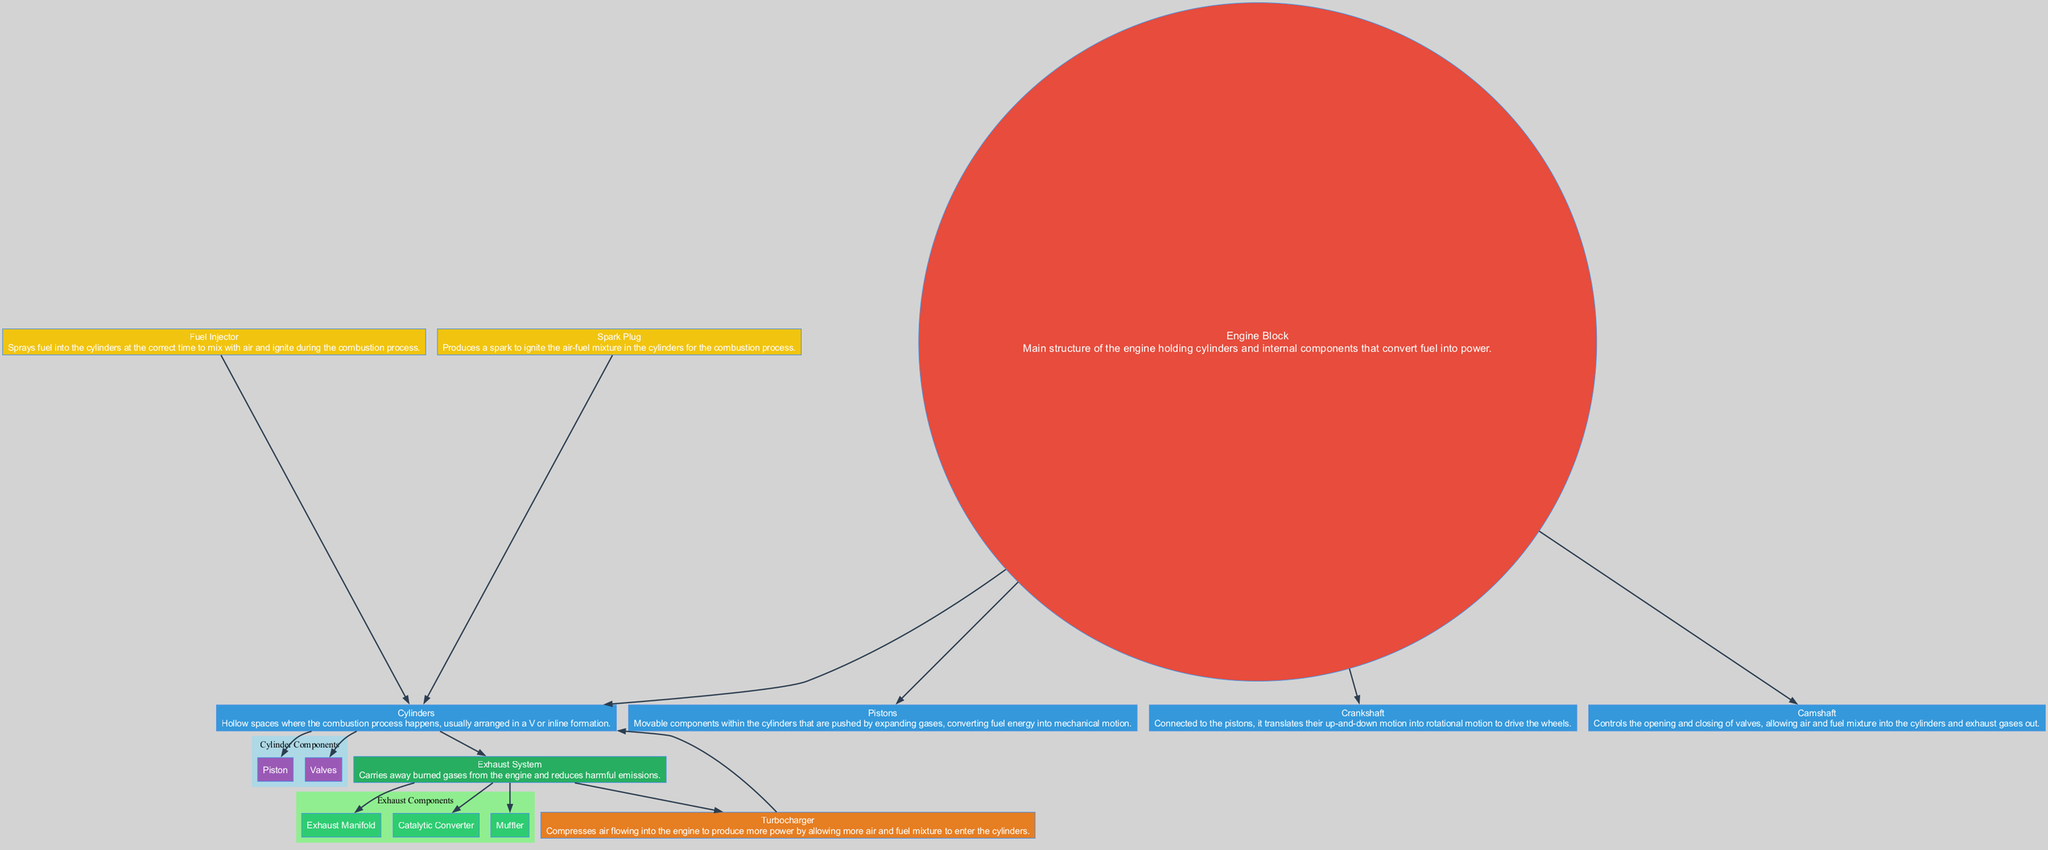What is the main structure of the engine called? The main structure, which holds the cylinders and internal components, is specifically referred to as the Engine Block.
Answer: Engine Block How many cylinders are typically present in a racing car engine? The diagram suggests that cylinders form the main component involved in combustion processes but does not specify a number. Racing car engines usually have many cylinders, often 4, 6, or 8; however, this cannot be directly determined from the given diagram.
Answer: Indeterminate Which component translates up-and-down motion into rotational motion? The Crankshaft is the component that receives the up-and-down motion from the pistons and converts it into rotational motion that drives the wheels.
Answer: Crankshaft What three components make up the Exhaust System? The Exhaust System consists of the Exhaust Manifold, Catalytic Converter, and Muffler, as indicated by the sub-components listed under it in the diagram.
Answer: Exhaust Manifold, Catalytic Converter, Muffler What is the role of the Turbocharger in the engine? The Turbocharger compresses the incoming air to increase power by allowing more air and fuel mixture into the cylinders, which is reflected in its description in the diagram.
Answer: Compresses air How does the Fuel Injector interact with the Cylinders? The Fuel Injector sprays fuel into the cylinders at the correct time, which means it provides the necessary fuel for the combustion that occurs within the cylinders. The directed edge from the Fuel Injector to the Cylinders illustrates this interaction.
Answer: Sprays fuel Which component is responsible for igniting the air-fuel mixture? The Spark Plug is responsible for producing a spark that ignites the air-fuel mixture inside the cylinders, as its role is represented in the diagram.
Answer: Spark Plug What is the primary function of the Camshaft? The Camshaft controls the opening and closing of valves, allowing the air-fuel mixture into the cylinders and also managing exhaust gases out, as stated in its description.
Answer: Controls valves What direction does the diagram's flow represent? The diagram flows from top to bottom, indicating the process of energy conversion and the relationship between different engine components as fuel is processed into power.
Answer: Top to bottom 